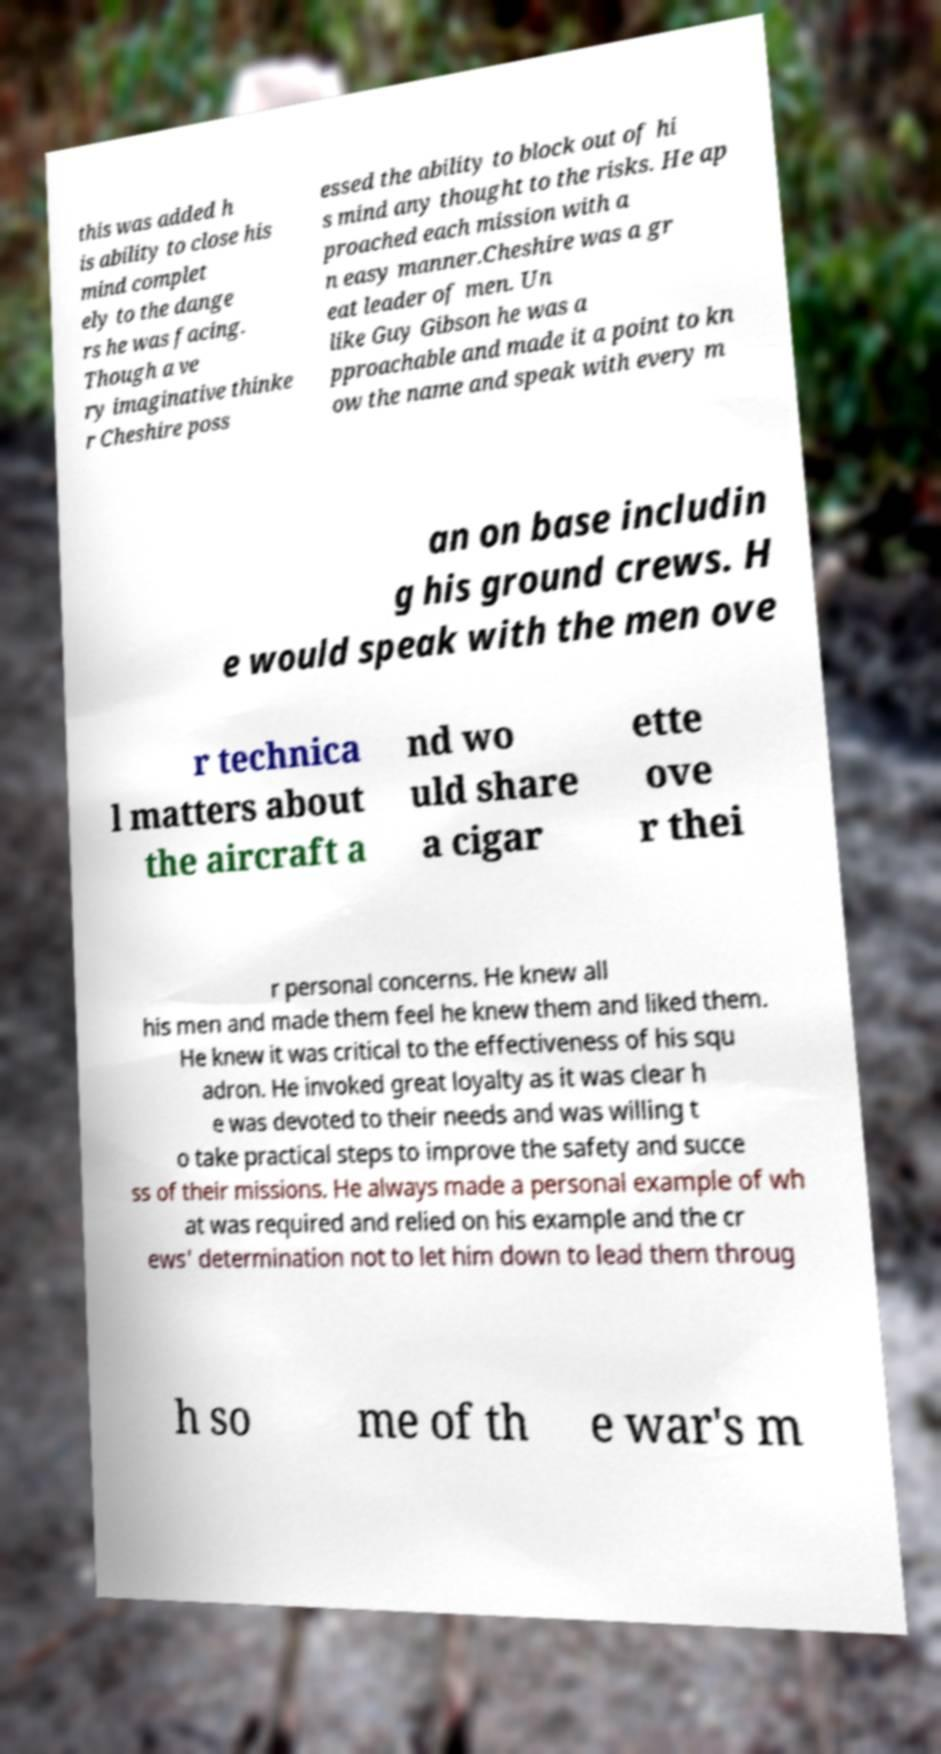Can you accurately transcribe the text from the provided image for me? this was added h is ability to close his mind complet ely to the dange rs he was facing. Though a ve ry imaginative thinke r Cheshire poss essed the ability to block out of hi s mind any thought to the risks. He ap proached each mission with a n easy manner.Cheshire was a gr eat leader of men. Un like Guy Gibson he was a pproachable and made it a point to kn ow the name and speak with every m an on base includin g his ground crews. H e would speak with the men ove r technica l matters about the aircraft a nd wo uld share a cigar ette ove r thei r personal concerns. He knew all his men and made them feel he knew them and liked them. He knew it was critical to the effectiveness of his squ adron. He invoked great loyalty as it was clear h e was devoted to their needs and was willing t o take practical steps to improve the safety and succe ss of their missions. He always made a personal example of wh at was required and relied on his example and the cr ews' determination not to let him down to lead them throug h so me of th e war's m 